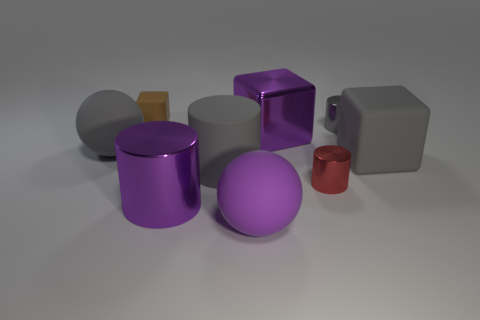The rubber sphere that is the same color as the matte cylinder is what size?
Make the answer very short. Large. There is a cylinder that is the same color as the large metal block; what material is it?
Your answer should be compact. Metal. The big metallic object that is in front of the big matte cube that is to the right of the tiny gray object is what shape?
Make the answer very short. Cylinder. There is a tiny gray cylinder; are there any purple blocks in front of it?
Keep it short and to the point. Yes. What color is the rubber cube that is the same size as the purple shiny block?
Keep it short and to the point. Gray. How many big blocks are the same material as the big gray ball?
Offer a terse response. 1. What number of other objects are there of the same size as the gray rubber cylinder?
Ensure brevity in your answer.  5. Is there a gray shiny cylinder that has the same size as the red shiny thing?
Provide a succinct answer. Yes. There is a block that is left of the big purple sphere; does it have the same color as the metal block?
Give a very brief answer. No. What number of things are tiny blue objects or tiny cubes?
Give a very brief answer. 1. 